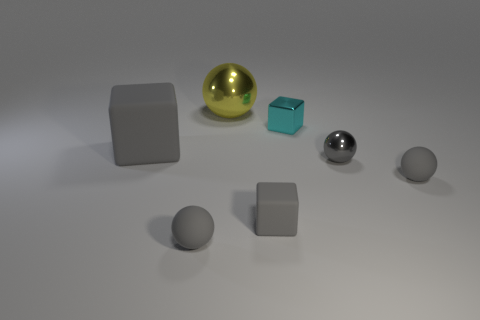There is a gray ball that is the same material as the cyan cube; what is its size?
Your answer should be very brief. Small. There is a small matte object that is to the left of the big thing to the right of the big matte block; what is its shape?
Your response must be concise. Sphere. There is a thing that is in front of the big gray block and on the left side of the yellow metallic sphere; what is its size?
Your answer should be compact. Small. Are there any large things that have the same shape as the small gray shiny object?
Offer a very short reply. Yes. What is the material of the big object that is right of the big gray cube that is in front of the cyan shiny cube in front of the large shiny sphere?
Your response must be concise. Metal. Is there a gray rubber cube that has the same size as the yellow shiny object?
Your answer should be compact. Yes. What is the color of the small metallic object that is left of the metal object that is in front of the cyan metallic object?
Your response must be concise. Cyan. How many big gray rubber objects are there?
Give a very brief answer. 1. Is the small matte block the same color as the big rubber cube?
Provide a short and direct response. Yes. Is the number of cyan objects that are on the left side of the tiny cyan metallic block less than the number of blocks that are behind the big matte block?
Ensure brevity in your answer.  Yes. 